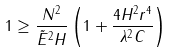Convert formula to latex. <formula><loc_0><loc_0><loc_500><loc_500>1 \geq \frac { N ^ { 2 } } { \tilde { E } ^ { 2 } H } \left ( 1 + \frac { 4 H ^ { 2 } r ^ { 4 } } { \lambda ^ { 2 } C } \right )</formula> 